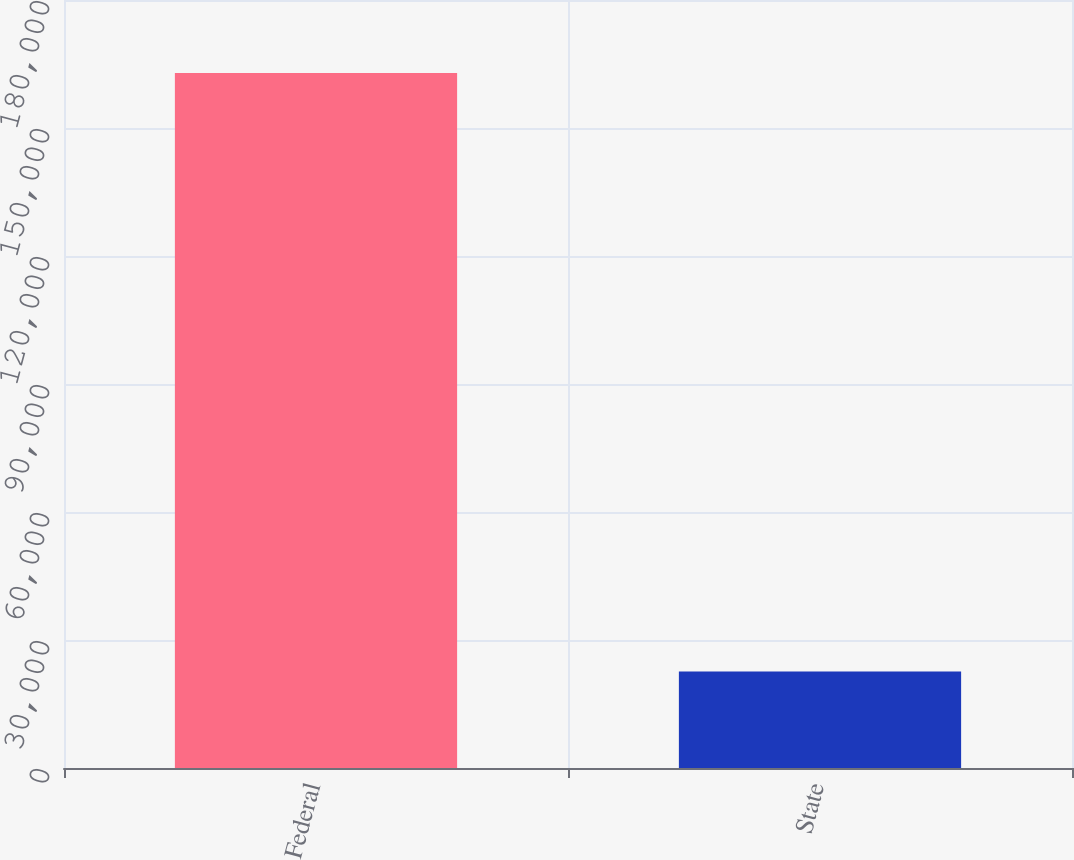Convert chart to OTSL. <chart><loc_0><loc_0><loc_500><loc_500><bar_chart><fcel>Federal<fcel>State<nl><fcel>162891<fcel>22626<nl></chart> 